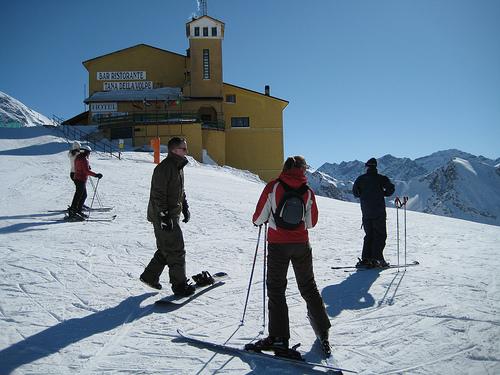Is it snowing?
Be succinct. No. How many people have snowboards?
Quick response, please. 1. Are these people dressed for the weather?
Concise answer only. Yes. Is there a restaurant on this hill?
Keep it brief. Yes. 